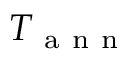Convert formula to latex. <formula><loc_0><loc_0><loc_500><loc_500>T _ { a n n }</formula> 